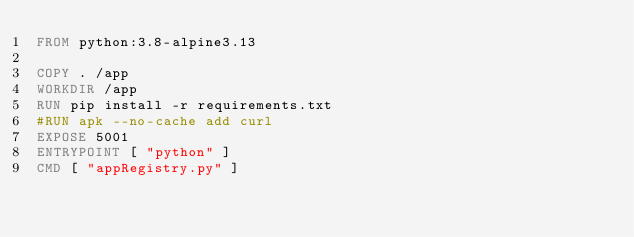<code> <loc_0><loc_0><loc_500><loc_500><_Dockerfile_>FROM python:3.8-alpine3.13

COPY . /app
WORKDIR /app
RUN pip install -r requirements.txt
#RUN apk --no-cache add curl
EXPOSE 5001
ENTRYPOINT [ "python" ]
CMD [ "appRegistry.py" ]</code> 